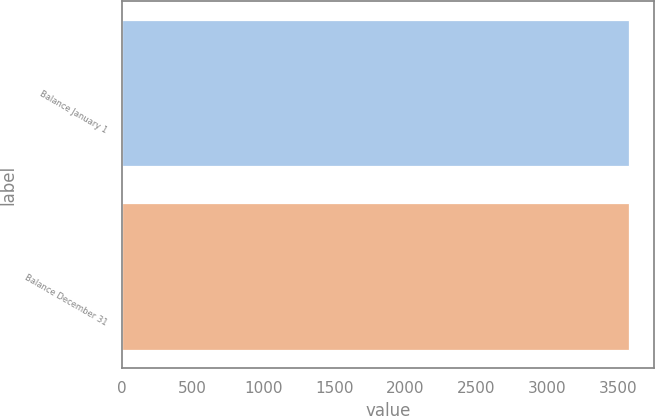Convert chart. <chart><loc_0><loc_0><loc_500><loc_500><bar_chart><fcel>Balance January 1<fcel>Balance December 31<nl><fcel>3577<fcel>3577.1<nl></chart> 